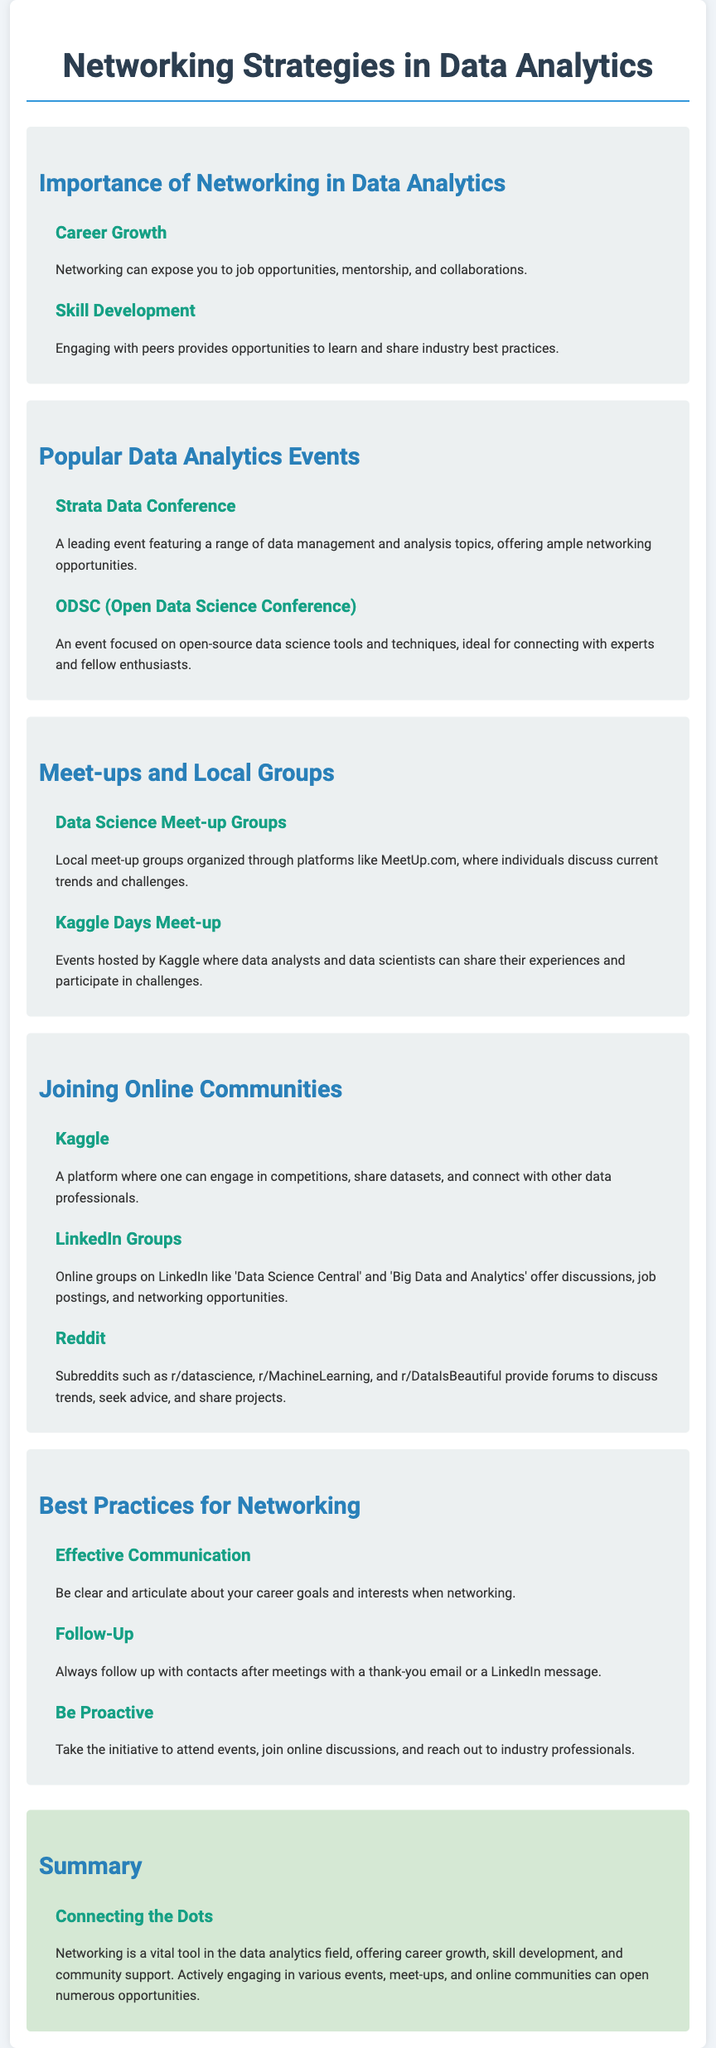what is the title of the document? The title is indicated at the top of the document as the main heading.
Answer: Networking Strategies in Data Analytics what event is focused on open-source data science tools? The event is specifically mentioned in the section about popular data analytics events.
Answer: ODSC (Open Data Science Conference) where can individuals discuss current trends and challenges in data science? This is detailed in the section about meet-ups and local groups in the document.
Answer: Data Science Meet-up Groups what is a key best practice for networking? Key practices are outlined in the corresponding section of the document.
Answer: Effective Communication which online community focuses on competitions and datasets? The online community is highlighted in the joining online communities section.
Answer: Kaggle how many popular data analytics events are listed? The number of events can be counted in the corresponding section of the document.
Answer: 2 what is one benefit of networking mentioned in the document? The benefits are described in the importance of networking section.
Answer: Career Growth what type of online groups does LinkedIn offer? This is mentioned in the section about joining online communities.
Answer: Discussions, job postings, and networking opportunities what should you do after meeting a contact? This is explained in the best practices for networking section.
Answer: Follow-Up 